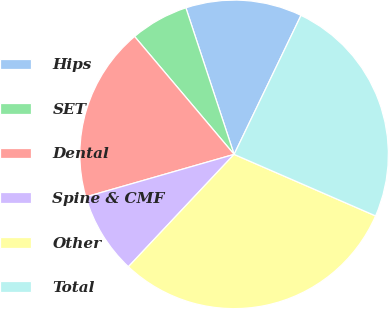Convert chart to OTSL. <chart><loc_0><loc_0><loc_500><loc_500><pie_chart><fcel>Hips<fcel>SET<fcel>Dental<fcel>Spine & CMF<fcel>Other<fcel>Total<nl><fcel>12.2%<fcel>6.1%<fcel>18.29%<fcel>8.54%<fcel>30.49%<fcel>24.39%<nl></chart> 